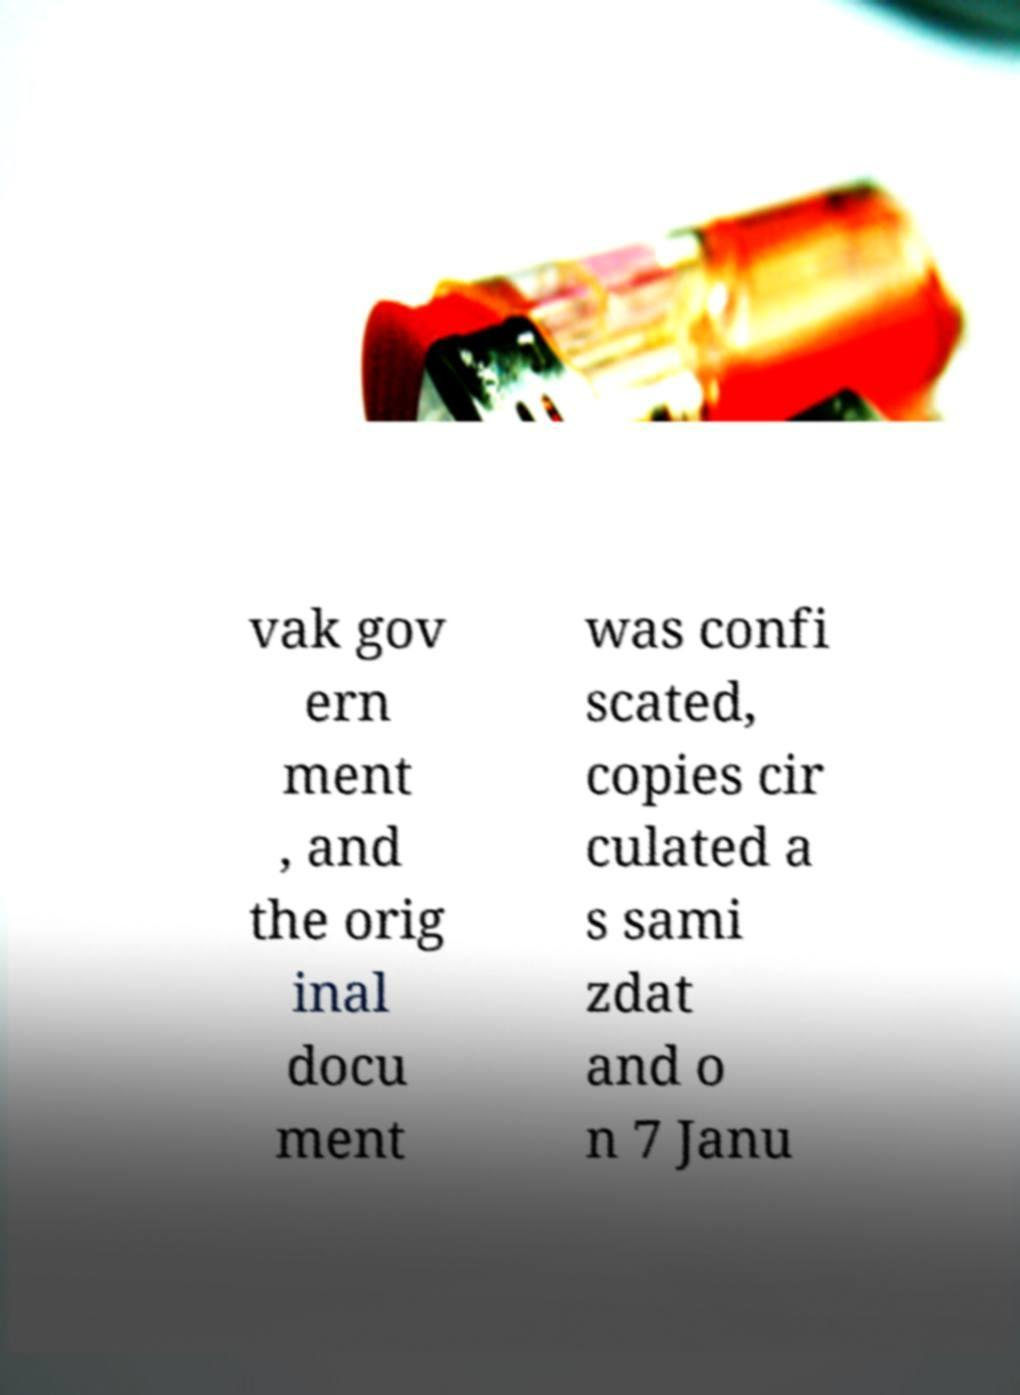Could you extract and type out the text from this image? vak gov ern ment , and the orig inal docu ment was confi scated, copies cir culated a s sami zdat and o n 7 Janu 